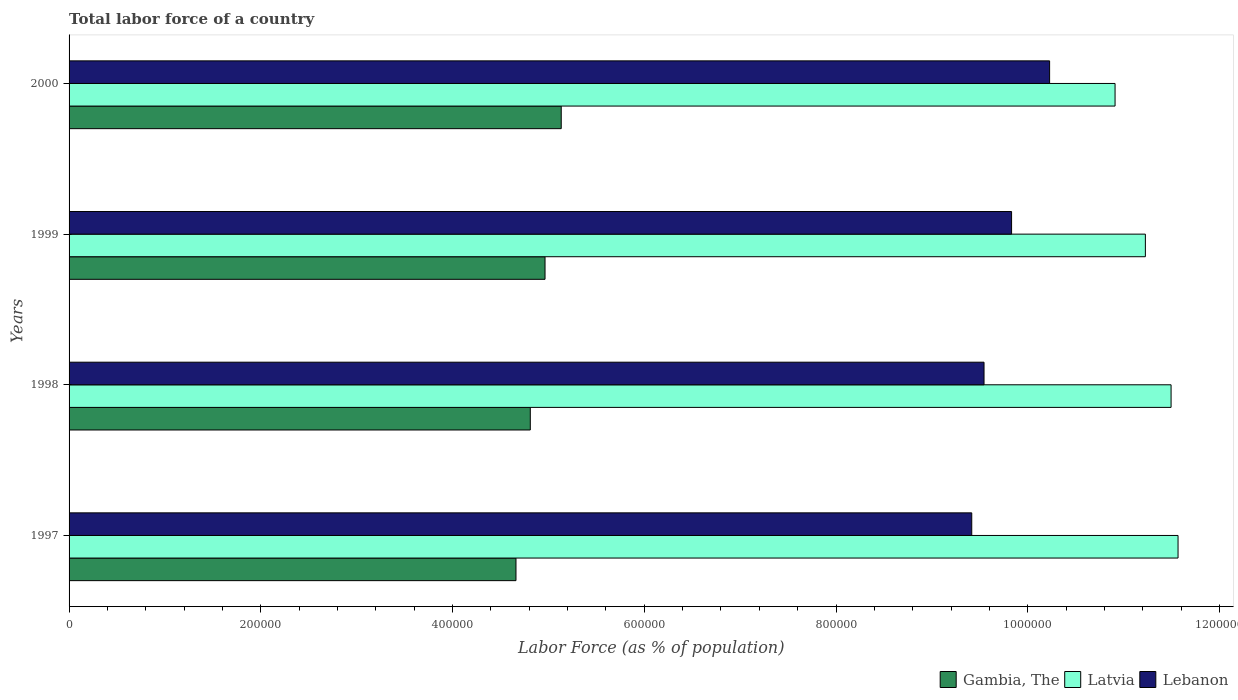How many different coloured bars are there?
Keep it short and to the point. 3. How many groups of bars are there?
Your answer should be very brief. 4. Are the number of bars per tick equal to the number of legend labels?
Your answer should be very brief. Yes. What is the label of the 3rd group of bars from the top?
Provide a short and direct response. 1998. In how many cases, is the number of bars for a given year not equal to the number of legend labels?
Provide a short and direct response. 0. What is the percentage of labor force in Lebanon in 1997?
Your answer should be compact. 9.42e+05. Across all years, what is the maximum percentage of labor force in Lebanon?
Make the answer very short. 1.02e+06. Across all years, what is the minimum percentage of labor force in Latvia?
Give a very brief answer. 1.09e+06. In which year was the percentage of labor force in Lebanon maximum?
Provide a succinct answer. 2000. In which year was the percentage of labor force in Gambia, The minimum?
Provide a succinct answer. 1997. What is the total percentage of labor force in Latvia in the graph?
Your answer should be very brief. 4.52e+06. What is the difference between the percentage of labor force in Latvia in 1997 and that in 1999?
Ensure brevity in your answer.  3.41e+04. What is the difference between the percentage of labor force in Lebanon in 1998 and the percentage of labor force in Gambia, The in 1997?
Provide a succinct answer. 4.88e+05. What is the average percentage of labor force in Gambia, The per year?
Offer a very short reply. 4.89e+05. In the year 2000, what is the difference between the percentage of labor force in Lebanon and percentage of labor force in Gambia, The?
Offer a very short reply. 5.09e+05. In how many years, is the percentage of labor force in Latvia greater than 880000 %?
Keep it short and to the point. 4. What is the ratio of the percentage of labor force in Latvia in 1998 to that in 1999?
Your answer should be compact. 1.02. Is the difference between the percentage of labor force in Lebanon in 1997 and 1999 greater than the difference between the percentage of labor force in Gambia, The in 1997 and 1999?
Your answer should be compact. No. What is the difference between the highest and the second highest percentage of labor force in Latvia?
Your answer should be very brief. 7266. What is the difference between the highest and the lowest percentage of labor force in Gambia, The?
Offer a terse response. 4.72e+04. What does the 2nd bar from the top in 2000 represents?
Provide a short and direct response. Latvia. What does the 1st bar from the bottom in 1998 represents?
Provide a succinct answer. Gambia, The. How many bars are there?
Keep it short and to the point. 12. How many years are there in the graph?
Keep it short and to the point. 4. What is the difference between two consecutive major ticks on the X-axis?
Keep it short and to the point. 2.00e+05. Are the values on the major ticks of X-axis written in scientific E-notation?
Provide a short and direct response. No. Does the graph contain grids?
Give a very brief answer. No. How many legend labels are there?
Keep it short and to the point. 3. What is the title of the graph?
Offer a terse response. Total labor force of a country. Does "Uzbekistan" appear as one of the legend labels in the graph?
Ensure brevity in your answer.  No. What is the label or title of the X-axis?
Keep it short and to the point. Labor Force (as % of population). What is the label or title of the Y-axis?
Offer a terse response. Years. What is the Labor Force (as % of population) of Gambia, The in 1997?
Offer a very short reply. 4.66e+05. What is the Labor Force (as % of population) in Latvia in 1997?
Keep it short and to the point. 1.16e+06. What is the Labor Force (as % of population) in Lebanon in 1997?
Your answer should be compact. 9.42e+05. What is the Labor Force (as % of population) of Gambia, The in 1998?
Give a very brief answer. 4.81e+05. What is the Labor Force (as % of population) of Latvia in 1998?
Make the answer very short. 1.15e+06. What is the Labor Force (as % of population) of Lebanon in 1998?
Offer a terse response. 9.54e+05. What is the Labor Force (as % of population) in Gambia, The in 1999?
Offer a terse response. 4.96e+05. What is the Labor Force (as % of population) in Latvia in 1999?
Keep it short and to the point. 1.12e+06. What is the Labor Force (as % of population) in Lebanon in 1999?
Offer a very short reply. 9.83e+05. What is the Labor Force (as % of population) in Gambia, The in 2000?
Your answer should be compact. 5.13e+05. What is the Labor Force (as % of population) of Latvia in 2000?
Your response must be concise. 1.09e+06. What is the Labor Force (as % of population) of Lebanon in 2000?
Your response must be concise. 1.02e+06. Across all years, what is the maximum Labor Force (as % of population) in Gambia, The?
Your response must be concise. 5.13e+05. Across all years, what is the maximum Labor Force (as % of population) of Latvia?
Your answer should be compact. 1.16e+06. Across all years, what is the maximum Labor Force (as % of population) in Lebanon?
Keep it short and to the point. 1.02e+06. Across all years, what is the minimum Labor Force (as % of population) in Gambia, The?
Your response must be concise. 4.66e+05. Across all years, what is the minimum Labor Force (as % of population) of Latvia?
Offer a terse response. 1.09e+06. Across all years, what is the minimum Labor Force (as % of population) in Lebanon?
Provide a succinct answer. 9.42e+05. What is the total Labor Force (as % of population) of Gambia, The in the graph?
Give a very brief answer. 1.96e+06. What is the total Labor Force (as % of population) in Latvia in the graph?
Provide a short and direct response. 4.52e+06. What is the total Labor Force (as % of population) in Lebanon in the graph?
Your response must be concise. 3.90e+06. What is the difference between the Labor Force (as % of population) of Gambia, The in 1997 and that in 1998?
Offer a very short reply. -1.49e+04. What is the difference between the Labor Force (as % of population) in Latvia in 1997 and that in 1998?
Give a very brief answer. 7266. What is the difference between the Labor Force (as % of population) in Lebanon in 1997 and that in 1998?
Give a very brief answer. -1.28e+04. What is the difference between the Labor Force (as % of population) in Gambia, The in 1997 and that in 1999?
Provide a succinct answer. -3.03e+04. What is the difference between the Labor Force (as % of population) of Latvia in 1997 and that in 1999?
Provide a short and direct response. 3.41e+04. What is the difference between the Labor Force (as % of population) of Lebanon in 1997 and that in 1999?
Provide a succinct answer. -4.16e+04. What is the difference between the Labor Force (as % of population) of Gambia, The in 1997 and that in 2000?
Keep it short and to the point. -4.72e+04. What is the difference between the Labor Force (as % of population) of Latvia in 1997 and that in 2000?
Offer a very short reply. 6.57e+04. What is the difference between the Labor Force (as % of population) of Lebanon in 1997 and that in 2000?
Keep it short and to the point. -8.12e+04. What is the difference between the Labor Force (as % of population) of Gambia, The in 1998 and that in 1999?
Your answer should be very brief. -1.54e+04. What is the difference between the Labor Force (as % of population) of Latvia in 1998 and that in 1999?
Give a very brief answer. 2.68e+04. What is the difference between the Labor Force (as % of population) in Lebanon in 1998 and that in 1999?
Your answer should be compact. -2.87e+04. What is the difference between the Labor Force (as % of population) of Gambia, The in 1998 and that in 2000?
Your answer should be compact. -3.23e+04. What is the difference between the Labor Force (as % of population) of Latvia in 1998 and that in 2000?
Provide a succinct answer. 5.84e+04. What is the difference between the Labor Force (as % of population) in Lebanon in 1998 and that in 2000?
Offer a terse response. -6.84e+04. What is the difference between the Labor Force (as % of population) of Gambia, The in 1999 and that in 2000?
Your answer should be compact. -1.69e+04. What is the difference between the Labor Force (as % of population) of Latvia in 1999 and that in 2000?
Your response must be concise. 3.16e+04. What is the difference between the Labor Force (as % of population) in Lebanon in 1999 and that in 2000?
Provide a succinct answer. -3.97e+04. What is the difference between the Labor Force (as % of population) in Gambia, The in 1997 and the Labor Force (as % of population) in Latvia in 1998?
Your response must be concise. -6.83e+05. What is the difference between the Labor Force (as % of population) of Gambia, The in 1997 and the Labor Force (as % of population) of Lebanon in 1998?
Ensure brevity in your answer.  -4.88e+05. What is the difference between the Labor Force (as % of population) of Latvia in 1997 and the Labor Force (as % of population) of Lebanon in 1998?
Your response must be concise. 2.02e+05. What is the difference between the Labor Force (as % of population) in Gambia, The in 1997 and the Labor Force (as % of population) in Latvia in 1999?
Your response must be concise. -6.57e+05. What is the difference between the Labor Force (as % of population) in Gambia, The in 1997 and the Labor Force (as % of population) in Lebanon in 1999?
Offer a terse response. -5.17e+05. What is the difference between the Labor Force (as % of population) of Latvia in 1997 and the Labor Force (as % of population) of Lebanon in 1999?
Offer a terse response. 1.74e+05. What is the difference between the Labor Force (as % of population) of Gambia, The in 1997 and the Labor Force (as % of population) of Latvia in 2000?
Ensure brevity in your answer.  -6.25e+05. What is the difference between the Labor Force (as % of population) of Gambia, The in 1997 and the Labor Force (as % of population) of Lebanon in 2000?
Offer a terse response. -5.57e+05. What is the difference between the Labor Force (as % of population) of Latvia in 1997 and the Labor Force (as % of population) of Lebanon in 2000?
Make the answer very short. 1.34e+05. What is the difference between the Labor Force (as % of population) of Gambia, The in 1998 and the Labor Force (as % of population) of Latvia in 1999?
Offer a terse response. -6.42e+05. What is the difference between the Labor Force (as % of population) in Gambia, The in 1998 and the Labor Force (as % of population) in Lebanon in 1999?
Keep it short and to the point. -5.02e+05. What is the difference between the Labor Force (as % of population) of Latvia in 1998 and the Labor Force (as % of population) of Lebanon in 1999?
Provide a succinct answer. 1.66e+05. What is the difference between the Labor Force (as % of population) of Gambia, The in 1998 and the Labor Force (as % of population) of Latvia in 2000?
Keep it short and to the point. -6.10e+05. What is the difference between the Labor Force (as % of population) in Gambia, The in 1998 and the Labor Force (as % of population) in Lebanon in 2000?
Offer a very short reply. -5.42e+05. What is the difference between the Labor Force (as % of population) of Latvia in 1998 and the Labor Force (as % of population) of Lebanon in 2000?
Provide a succinct answer. 1.27e+05. What is the difference between the Labor Force (as % of population) in Gambia, The in 1999 and the Labor Force (as % of population) in Latvia in 2000?
Provide a short and direct response. -5.95e+05. What is the difference between the Labor Force (as % of population) of Gambia, The in 1999 and the Labor Force (as % of population) of Lebanon in 2000?
Your response must be concise. -5.26e+05. What is the difference between the Labor Force (as % of population) of Latvia in 1999 and the Labor Force (as % of population) of Lebanon in 2000?
Offer a very short reply. 9.99e+04. What is the average Labor Force (as % of population) of Gambia, The per year?
Your response must be concise. 4.89e+05. What is the average Labor Force (as % of population) of Latvia per year?
Ensure brevity in your answer.  1.13e+06. What is the average Labor Force (as % of population) of Lebanon per year?
Your answer should be very brief. 9.75e+05. In the year 1997, what is the difference between the Labor Force (as % of population) of Gambia, The and Labor Force (as % of population) of Latvia?
Your answer should be compact. -6.91e+05. In the year 1997, what is the difference between the Labor Force (as % of population) in Gambia, The and Labor Force (as % of population) in Lebanon?
Offer a very short reply. -4.75e+05. In the year 1997, what is the difference between the Labor Force (as % of population) of Latvia and Labor Force (as % of population) of Lebanon?
Keep it short and to the point. 2.15e+05. In the year 1998, what is the difference between the Labor Force (as % of population) in Gambia, The and Labor Force (as % of population) in Latvia?
Make the answer very short. -6.68e+05. In the year 1998, what is the difference between the Labor Force (as % of population) in Gambia, The and Labor Force (as % of population) in Lebanon?
Your response must be concise. -4.73e+05. In the year 1998, what is the difference between the Labor Force (as % of population) of Latvia and Labor Force (as % of population) of Lebanon?
Offer a very short reply. 1.95e+05. In the year 1999, what is the difference between the Labor Force (as % of population) of Gambia, The and Labor Force (as % of population) of Latvia?
Provide a short and direct response. -6.26e+05. In the year 1999, what is the difference between the Labor Force (as % of population) of Gambia, The and Labor Force (as % of population) of Lebanon?
Provide a short and direct response. -4.87e+05. In the year 1999, what is the difference between the Labor Force (as % of population) of Latvia and Labor Force (as % of population) of Lebanon?
Your answer should be compact. 1.40e+05. In the year 2000, what is the difference between the Labor Force (as % of population) in Gambia, The and Labor Force (as % of population) in Latvia?
Give a very brief answer. -5.78e+05. In the year 2000, what is the difference between the Labor Force (as % of population) in Gambia, The and Labor Force (as % of population) in Lebanon?
Your answer should be very brief. -5.09e+05. In the year 2000, what is the difference between the Labor Force (as % of population) of Latvia and Labor Force (as % of population) of Lebanon?
Make the answer very short. 6.83e+04. What is the ratio of the Labor Force (as % of population) in Gambia, The in 1997 to that in 1998?
Keep it short and to the point. 0.97. What is the ratio of the Labor Force (as % of population) in Lebanon in 1997 to that in 1998?
Offer a very short reply. 0.99. What is the ratio of the Labor Force (as % of population) in Gambia, The in 1997 to that in 1999?
Provide a succinct answer. 0.94. What is the ratio of the Labor Force (as % of population) of Latvia in 1997 to that in 1999?
Ensure brevity in your answer.  1.03. What is the ratio of the Labor Force (as % of population) of Lebanon in 1997 to that in 1999?
Your answer should be compact. 0.96. What is the ratio of the Labor Force (as % of population) of Gambia, The in 1997 to that in 2000?
Provide a succinct answer. 0.91. What is the ratio of the Labor Force (as % of population) of Latvia in 1997 to that in 2000?
Offer a very short reply. 1.06. What is the ratio of the Labor Force (as % of population) in Lebanon in 1997 to that in 2000?
Offer a very short reply. 0.92. What is the ratio of the Labor Force (as % of population) in Gambia, The in 1998 to that in 1999?
Ensure brevity in your answer.  0.97. What is the ratio of the Labor Force (as % of population) in Latvia in 1998 to that in 1999?
Your response must be concise. 1.02. What is the ratio of the Labor Force (as % of population) in Lebanon in 1998 to that in 1999?
Your response must be concise. 0.97. What is the ratio of the Labor Force (as % of population) in Gambia, The in 1998 to that in 2000?
Your answer should be compact. 0.94. What is the ratio of the Labor Force (as % of population) of Latvia in 1998 to that in 2000?
Your response must be concise. 1.05. What is the ratio of the Labor Force (as % of population) of Lebanon in 1998 to that in 2000?
Provide a short and direct response. 0.93. What is the ratio of the Labor Force (as % of population) in Gambia, The in 1999 to that in 2000?
Provide a succinct answer. 0.97. What is the ratio of the Labor Force (as % of population) in Lebanon in 1999 to that in 2000?
Offer a very short reply. 0.96. What is the difference between the highest and the second highest Labor Force (as % of population) in Gambia, The?
Provide a succinct answer. 1.69e+04. What is the difference between the highest and the second highest Labor Force (as % of population) in Latvia?
Ensure brevity in your answer.  7266. What is the difference between the highest and the second highest Labor Force (as % of population) of Lebanon?
Your answer should be compact. 3.97e+04. What is the difference between the highest and the lowest Labor Force (as % of population) of Gambia, The?
Keep it short and to the point. 4.72e+04. What is the difference between the highest and the lowest Labor Force (as % of population) in Latvia?
Make the answer very short. 6.57e+04. What is the difference between the highest and the lowest Labor Force (as % of population) of Lebanon?
Keep it short and to the point. 8.12e+04. 